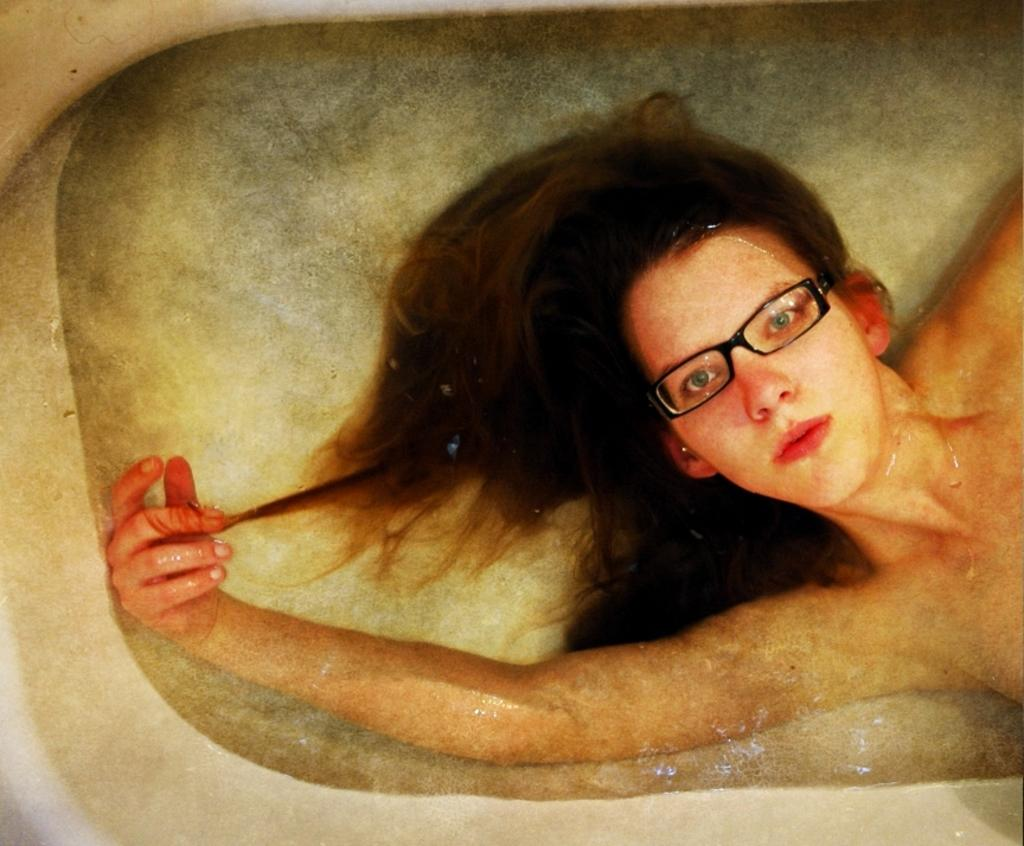What is the woman doing in the image? The woman is in a white tub filled with water. What is the woman wearing in the image? The woman is wearing glasses in the image. What type of lock is visible on the window in the image? There is no window or lock present in the image; it only features a woman in a white tub filled with water. 